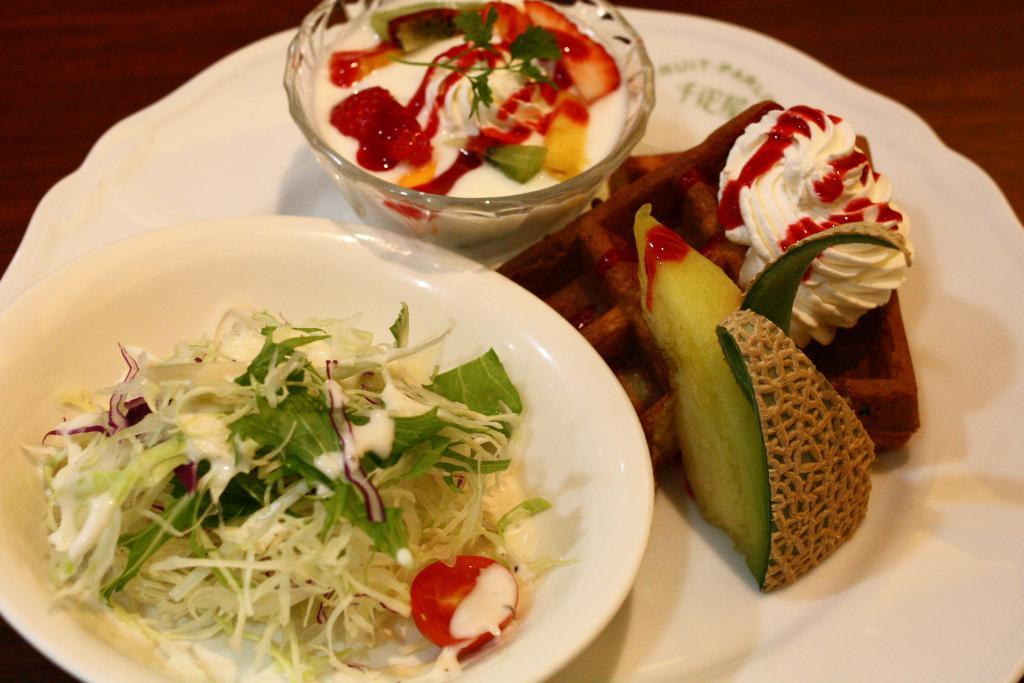What is on the plate that is visible in the image? There are food items in bowls on a plate. Where is the plate with food items located? The plate with food items is placed on a table. What type of motion can be seen in the kettle in the image? There is no kettle present in the image. 